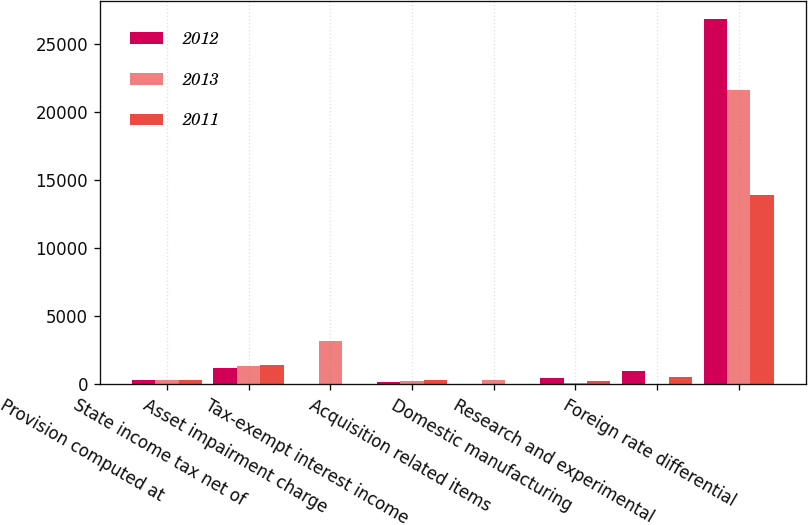<chart> <loc_0><loc_0><loc_500><loc_500><stacked_bar_chart><ecel><fcel>Provision computed at<fcel>State income tax net of<fcel>Asset impairment charge<fcel>Tax-exempt interest income<fcel>Acquisition related items<fcel>Domestic manufacturing<fcel>Research and experimental<fcel>Foreign rate differential<nl><fcel>2012<fcel>334<fcel>1191<fcel>0<fcel>174<fcel>0<fcel>490<fcel>970<fcel>26798<nl><fcel>2013<fcel>334<fcel>1353<fcel>3190<fcel>230<fcel>322<fcel>105<fcel>0<fcel>21598<nl><fcel>2011<fcel>334<fcel>1432<fcel>0<fcel>334<fcel>0<fcel>212<fcel>508<fcel>13899<nl></chart> 